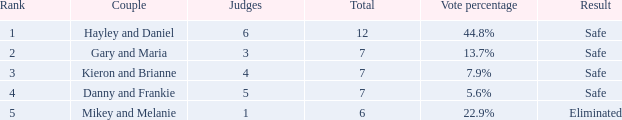Could you parse the entire table as a dict? {'header': ['Rank', 'Couple', 'Judges', 'Total', 'Vote percentage', 'Result'], 'rows': [['1', 'Hayley and Daniel', '6', '12', '44.8%', 'Safe'], ['2', 'Gary and Maria', '3', '7', '13.7%', 'Safe'], ['3', 'Kieron and Brianne', '4', '7', '7.9%', 'Safe'], ['4', 'Danny and Frankie', '5', '7', '5.6%', 'Safe'], ['5', 'Mikey and Melanie', '1', '6', '22.9%', 'Eliminated']]} What was the consequence for the total of 12? Safe. 